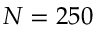<formula> <loc_0><loc_0><loc_500><loc_500>N = 2 5 0</formula> 